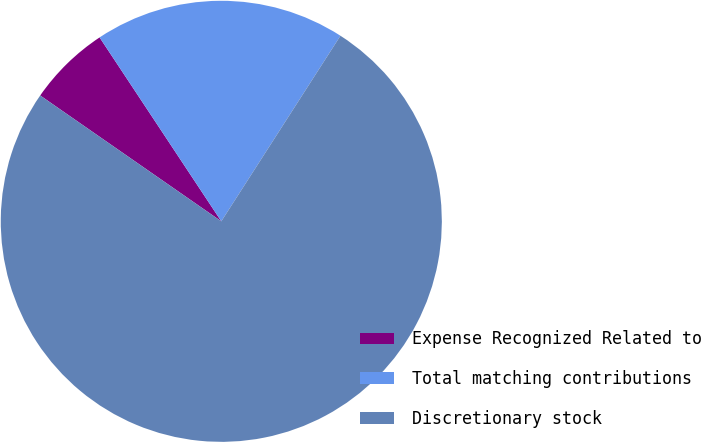<chart> <loc_0><loc_0><loc_500><loc_500><pie_chart><fcel>Expense Recognized Related to<fcel>Total matching contributions<fcel>Discretionary stock<nl><fcel>6.03%<fcel>18.39%<fcel>75.58%<nl></chart> 